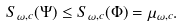<formula> <loc_0><loc_0><loc_500><loc_500>S _ { \omega , c } ( \Psi ) \leq S _ { \omega , c } ( \Phi ) = \mu _ { \omega , c } .</formula> 